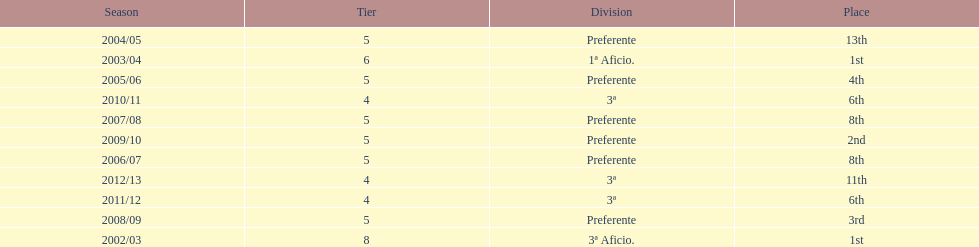In what year did the group accomplish the same rank as 2010/11? 2011/12. 